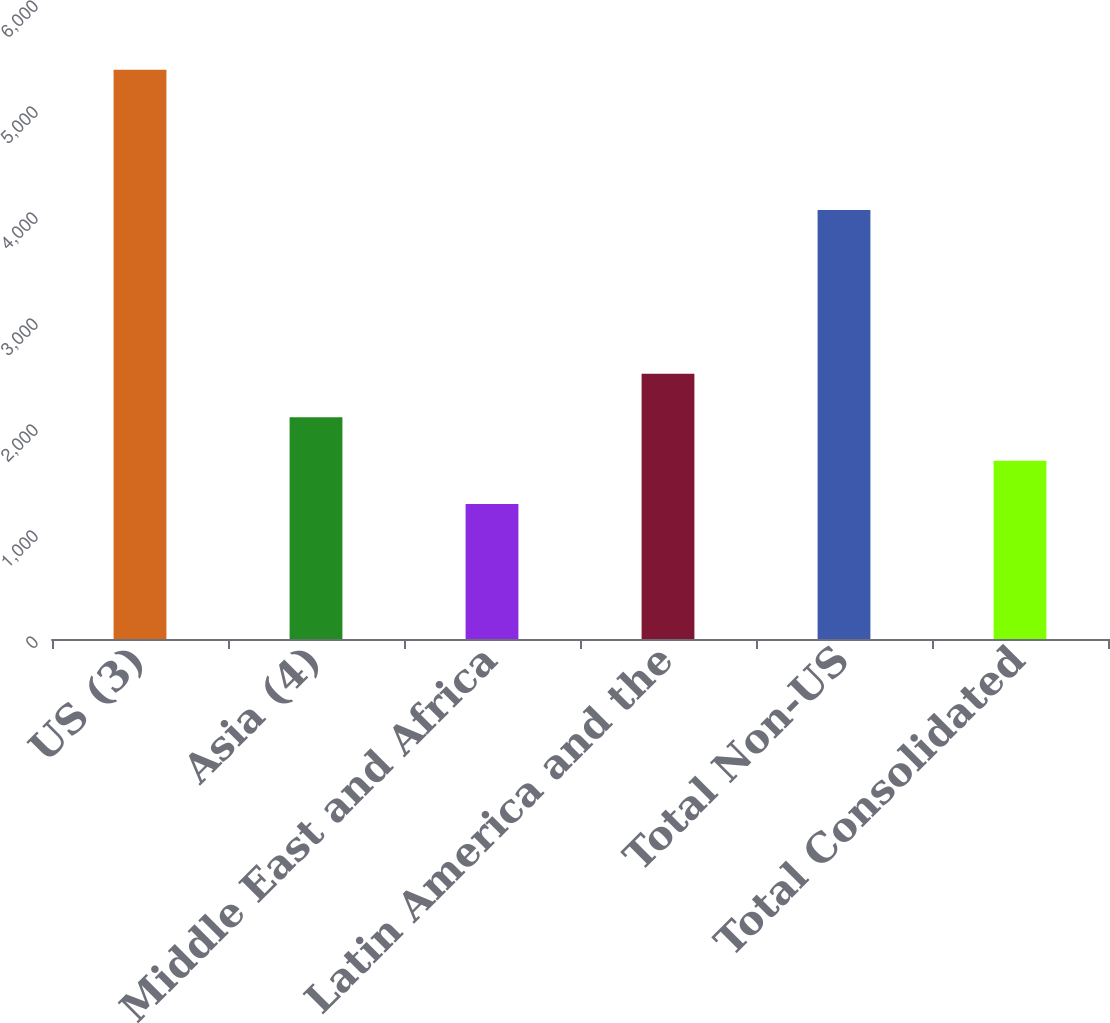Convert chart to OTSL. <chart><loc_0><loc_0><loc_500><loc_500><bar_chart><fcel>US (3)<fcel>Asia (4)<fcel>Europe Middle East and Africa<fcel>Latin America and the<fcel>Total Non-US<fcel>Total Consolidated<nl><fcel>5370<fcel>2092.4<fcel>1273<fcel>2502.1<fcel>4047<fcel>1682.7<nl></chart> 